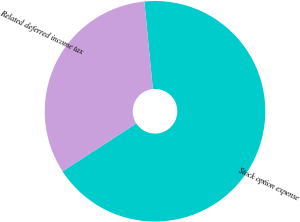Convert chart to OTSL. <chart><loc_0><loc_0><loc_500><loc_500><pie_chart><fcel>Stock option expense<fcel>Related deferred income tax<nl><fcel>67.37%<fcel>32.63%<nl></chart> 